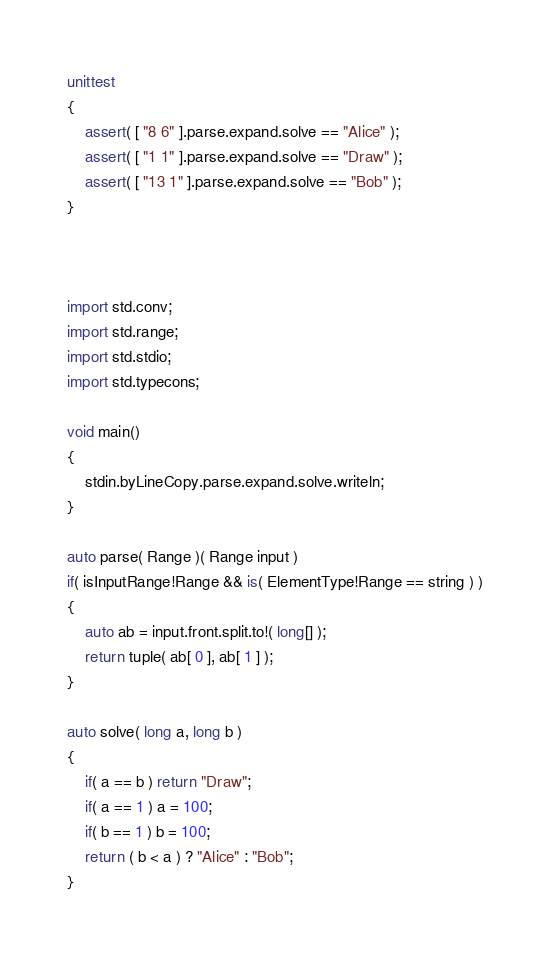<code> <loc_0><loc_0><loc_500><loc_500><_D_>unittest
{
	assert( [ "8 6" ].parse.expand.solve == "Alice" );
	assert( [ "1 1" ].parse.expand.solve == "Draw" );
	assert( [ "13 1" ].parse.expand.solve == "Bob" );
}



import std.conv;
import std.range;
import std.stdio;
import std.typecons;

void main()
{
	stdin.byLineCopy.parse.expand.solve.writeln;
}

auto parse( Range )( Range input )
if( isInputRange!Range && is( ElementType!Range == string ) )
{
	auto ab = input.front.split.to!( long[] );
	return tuple( ab[ 0 ], ab[ 1 ] );
}

auto solve( long a, long b )
{
	if( a == b ) return "Draw";
	if( a == 1 ) a = 100;
	if( b == 1 ) b = 100;
	return ( b < a ) ? "Alice" : "Bob";
}
</code> 